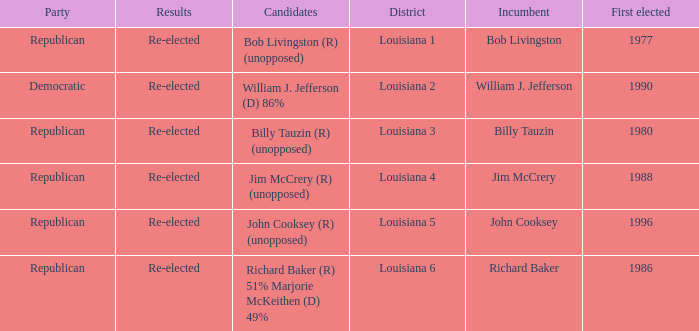What district does John Cooksey represent? Louisiana 5. 